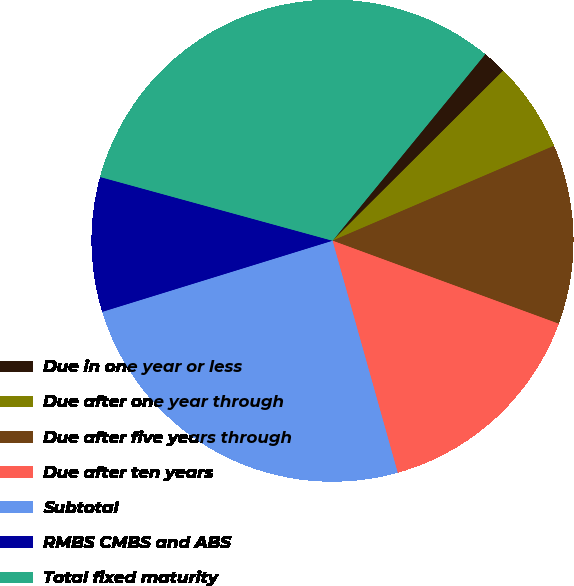Convert chart. <chart><loc_0><loc_0><loc_500><loc_500><pie_chart><fcel>Due in one year or less<fcel>Due after one year through<fcel>Due after five years through<fcel>Due after ten years<fcel>Subtotal<fcel>RMBS CMBS and ABS<fcel>Total fixed maturity<nl><fcel>1.61%<fcel>6.03%<fcel>12.04%<fcel>15.04%<fcel>24.59%<fcel>9.03%<fcel>31.66%<nl></chart> 